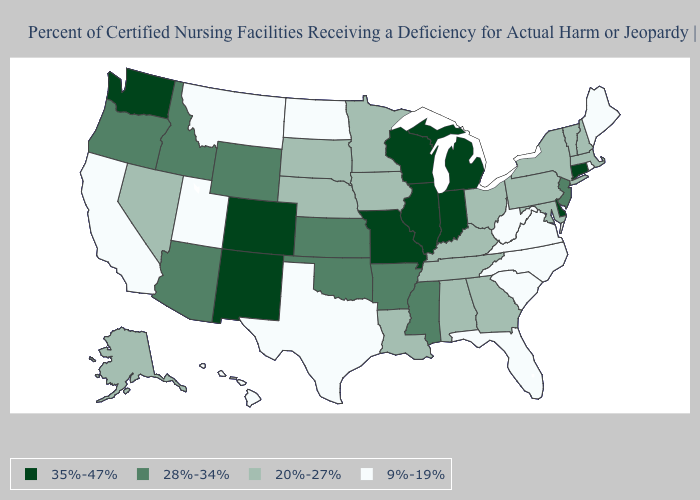Does the map have missing data?
Give a very brief answer. No. Does North Carolina have the lowest value in the South?
Write a very short answer. Yes. Does Connecticut have the highest value in the USA?
Answer briefly. Yes. Among the states that border Missouri , which have the lowest value?
Give a very brief answer. Iowa, Kentucky, Nebraska, Tennessee. Which states have the lowest value in the West?
Short answer required. California, Hawaii, Montana, Utah. What is the value of New Mexico?
Give a very brief answer. 35%-47%. What is the highest value in the USA?
Concise answer only. 35%-47%. Which states hav the highest value in the West?
Give a very brief answer. Colorado, New Mexico, Washington. What is the value of Iowa?
Answer briefly. 20%-27%. Among the states that border Texas , does New Mexico have the highest value?
Quick response, please. Yes. What is the highest value in the USA?
Concise answer only. 35%-47%. How many symbols are there in the legend?
Short answer required. 4. What is the value of North Carolina?
Give a very brief answer. 9%-19%. Name the states that have a value in the range 35%-47%?
Write a very short answer. Colorado, Connecticut, Delaware, Illinois, Indiana, Michigan, Missouri, New Mexico, Washington, Wisconsin. Name the states that have a value in the range 35%-47%?
Answer briefly. Colorado, Connecticut, Delaware, Illinois, Indiana, Michigan, Missouri, New Mexico, Washington, Wisconsin. 